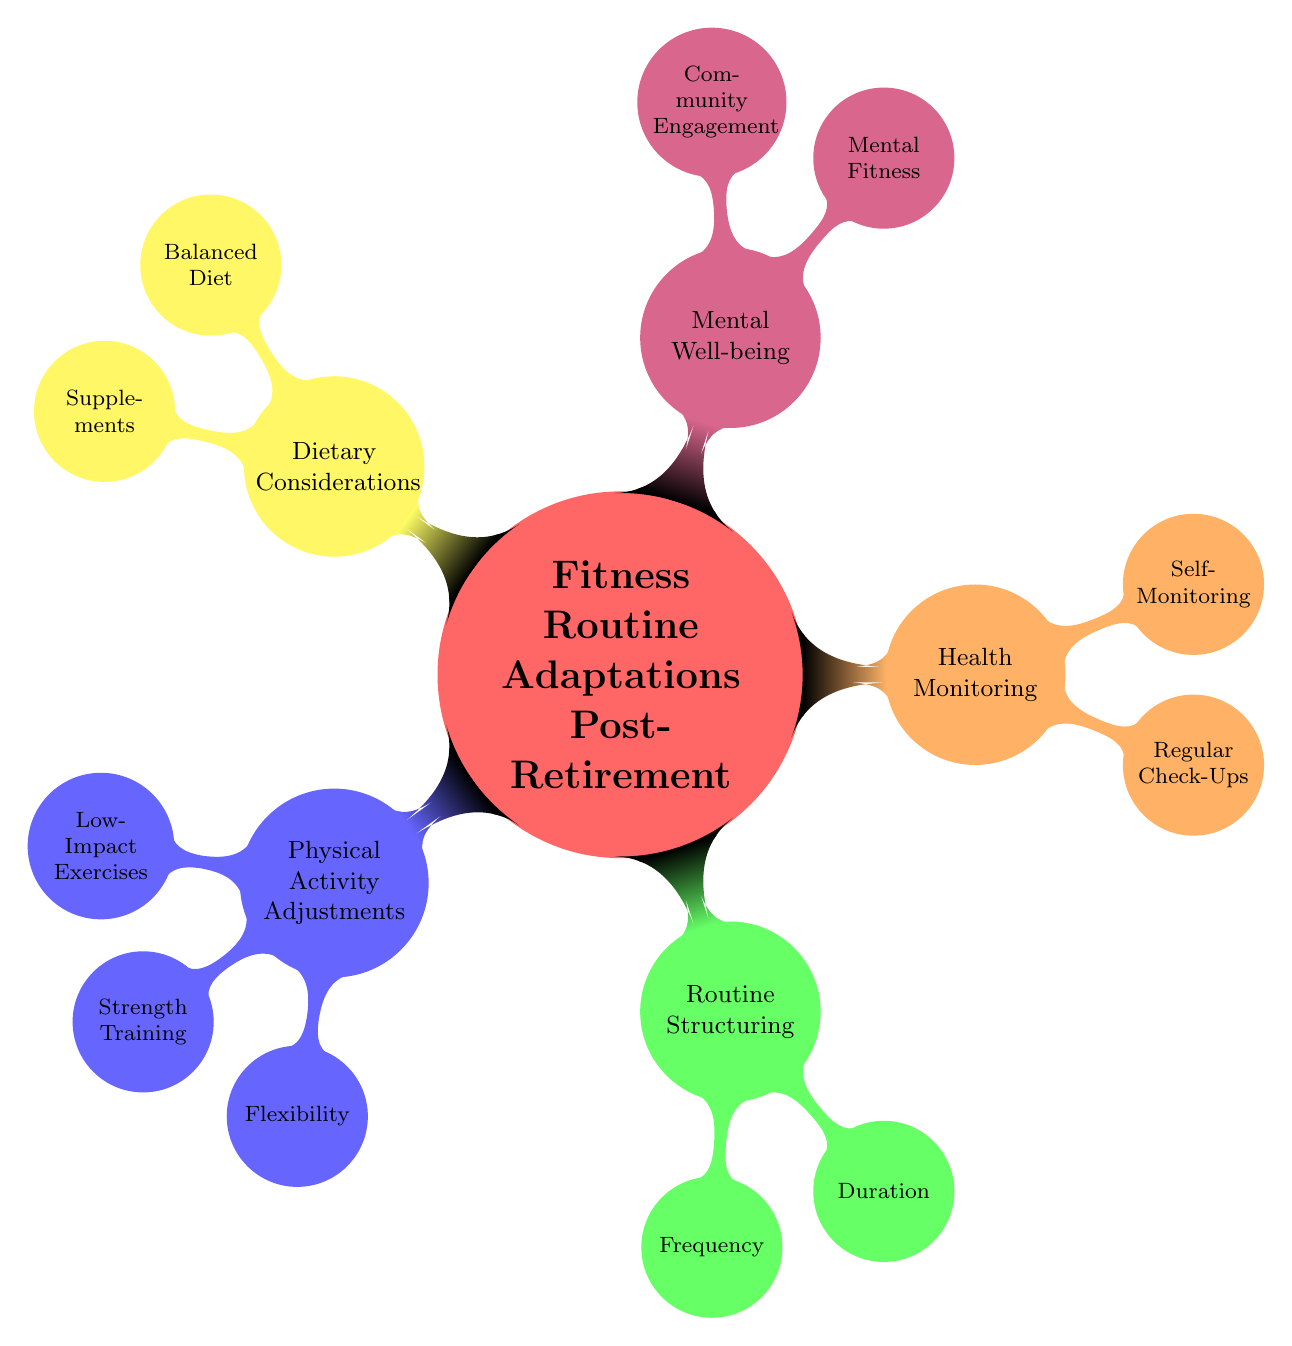What are the two main categories under "Health Monitoring"? To answer this, we look at the main node "Health Monitoring," which has two child nodes directly linked to it: "Regular Check-Ups" and "Self-Monitoring."
Answer: Regular Check-Ups, Self-Monitoring How many types of "Low-Impact Exercises" are listed? The node "Low-Impact Exercises" has three items: "Swimming," "Cycling," and "Yoga." Counting these gives us a total of three types.
Answer: 3 What is the recommended frequency for the fitness routine? The node "Frequency" under "Routine Structuring" lists three items: "3-4 Days per Week," "Rest Days," and "Active Recovery." Here, "3-4 Days per Week" is the specific recommended frequency.
Answer: 3-4 Days per Week Which two aspects of "Mental Well-being" focus on community? From the node "Mental Well-being," we identify two child nodes: "Mental Fitness" and "Community Engagement." The specific aspect that emphasizes community is "Community Engagement."
Answer: Community Engagement What types of exercises are included in "Strength Training"? Looking under the node "Strength Training," we see three types of exercises listed: "Bodyweight Exercises," "Resistance Bands," and "Light Weights." Therefore, the types of exercises are those three.
Answer: Bodyweight Exercises, Resistance Bands, Light Weights How many total sections are in "Fitness Routine Adaptations Post-Retirement"? The main node has five distinct child nodes: "Physical Activity Adjustments," "Routine Structuring," "Health Monitoring," "Mental Well-being," and "Dietary Considerations." Counting these gives us a total of five sections.
Answer: 5 What are the three items listed under "Balanced Diet"? The node "Balanced Diet" has three child food types mentioned: "Protein-Rich Foods," "Whole Grains," and "Healthy Fats." These can be directly referenced for the items.
Answer: Protein-Rich Foods, Whole Grains, Healthy Fats What is the duration of the fitness sessions recommended? Under the node "Duration" in the "Routine Structuring," it specifically states "30-45 Minutes per Session" as the recommended duration. This is the concise response for the question.
Answer: 30-45 Minutes per Session 